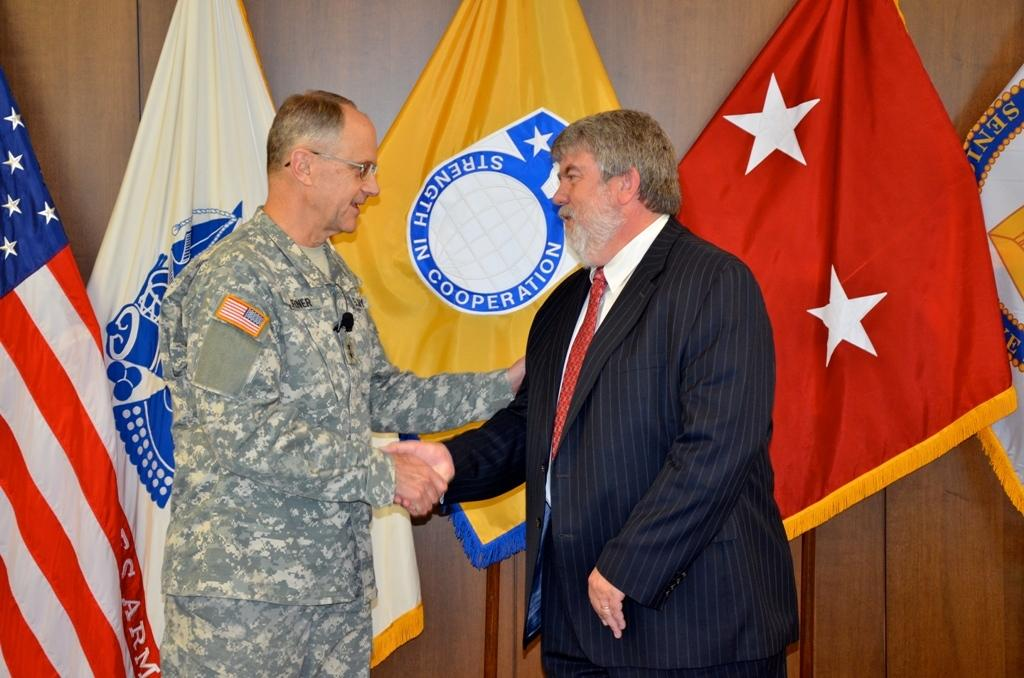How many people are in the image? There are two persons in the image. What are the two persons doing? The two persons are shaking hands. What can be seen in the background of the image? There are flags and a wooden wall visible in the background. How many bricks are visible in the image? There are no bricks visible in the image; the background features flags and a wooden wall. What type of jellyfish can be seen swimming in the background? There are no jellyfish present in the image; the background features flags and a wooden wall. 